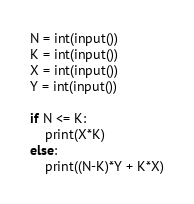Convert code to text. <code><loc_0><loc_0><loc_500><loc_500><_Python_>
N = int(input())
K = int(input())
X = int(input())
Y = int(input())

if N <= K:
    print(X*K)
else:
    print((N-K)*Y + K*X)
</code> 